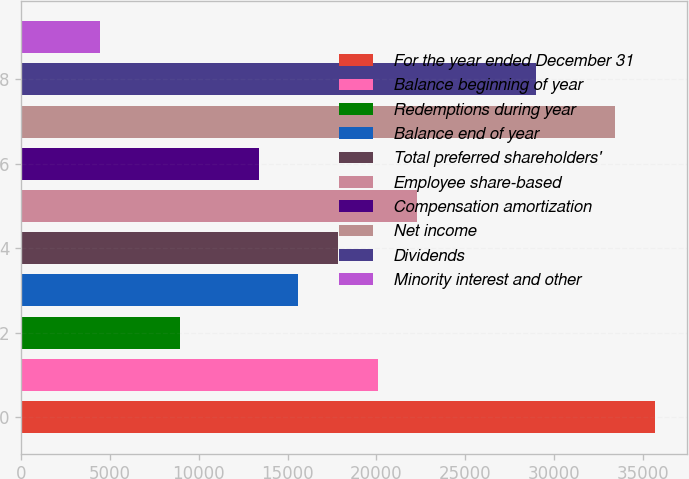Convert chart. <chart><loc_0><loc_0><loc_500><loc_500><bar_chart><fcel>For the year ended December 31<fcel>Balance beginning of year<fcel>Redemptions during year<fcel>Balance end of year<fcel>Total preferred shareholders'<fcel>Employee share-based<fcel>Compensation amortization<fcel>Net income<fcel>Dividends<fcel>Minority interest and other<nl><fcel>35680.1<fcel>20073.5<fcel>8925.94<fcel>15614.5<fcel>17844<fcel>22303<fcel>13385<fcel>33450.6<fcel>28991.5<fcel>4466.92<nl></chart> 